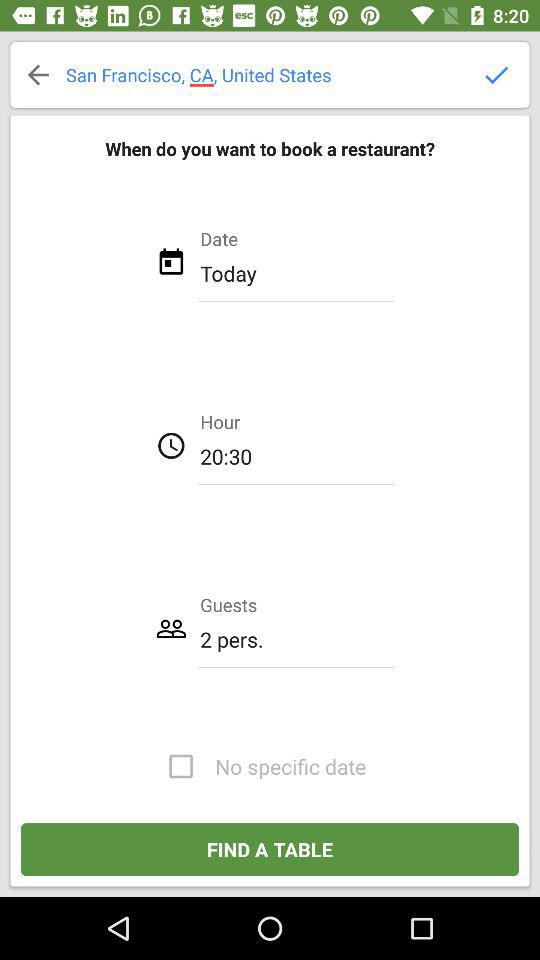For how many guests do I have to book a restaurant? You have to book a restaurant for 2 guests. 